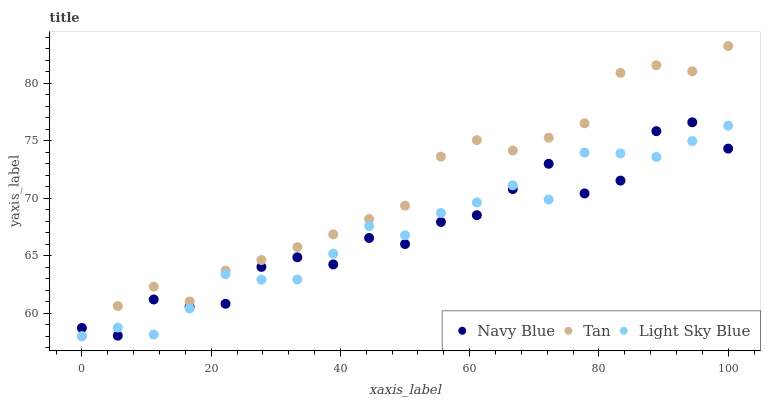Does Navy Blue have the minimum area under the curve?
Answer yes or no. Yes. Does Tan have the maximum area under the curve?
Answer yes or no. Yes. Does Light Sky Blue have the minimum area under the curve?
Answer yes or no. No. Does Light Sky Blue have the maximum area under the curve?
Answer yes or no. No. Is Tan the smoothest?
Answer yes or no. Yes. Is Navy Blue the roughest?
Answer yes or no. Yes. Is Light Sky Blue the smoothest?
Answer yes or no. No. Is Light Sky Blue the roughest?
Answer yes or no. No. Does Tan have the lowest value?
Answer yes or no. Yes. Does Tan have the highest value?
Answer yes or no. Yes. Does Light Sky Blue have the highest value?
Answer yes or no. No. Does Light Sky Blue intersect Navy Blue?
Answer yes or no. Yes. Is Light Sky Blue less than Navy Blue?
Answer yes or no. No. Is Light Sky Blue greater than Navy Blue?
Answer yes or no. No. 